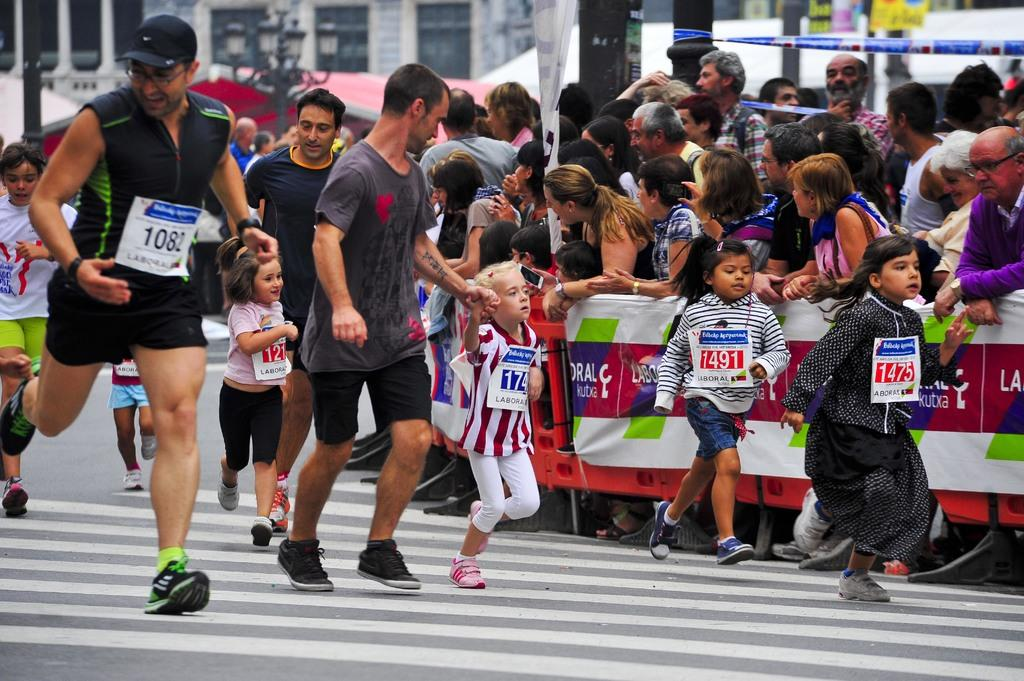What activity are the people on the road involved in? The people on the road are participating in a marathon. Are there any specific participants in the marathon? Yes, there are kids participating in the marathon. Who else is present during the marathon? There is a group of people standing and watching the marathon. What can be seen in the background of the image? There is a building visible in the background. What type of kick can be seen in the image? There is no kick present in the image; it features people participating in a marathon, which is a running event. What kind of rod is being used by the participants in the marathon? There is no rod present in the image; the participants are running without any equipment. 